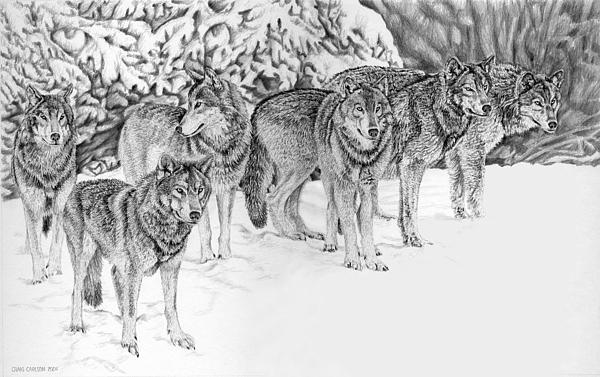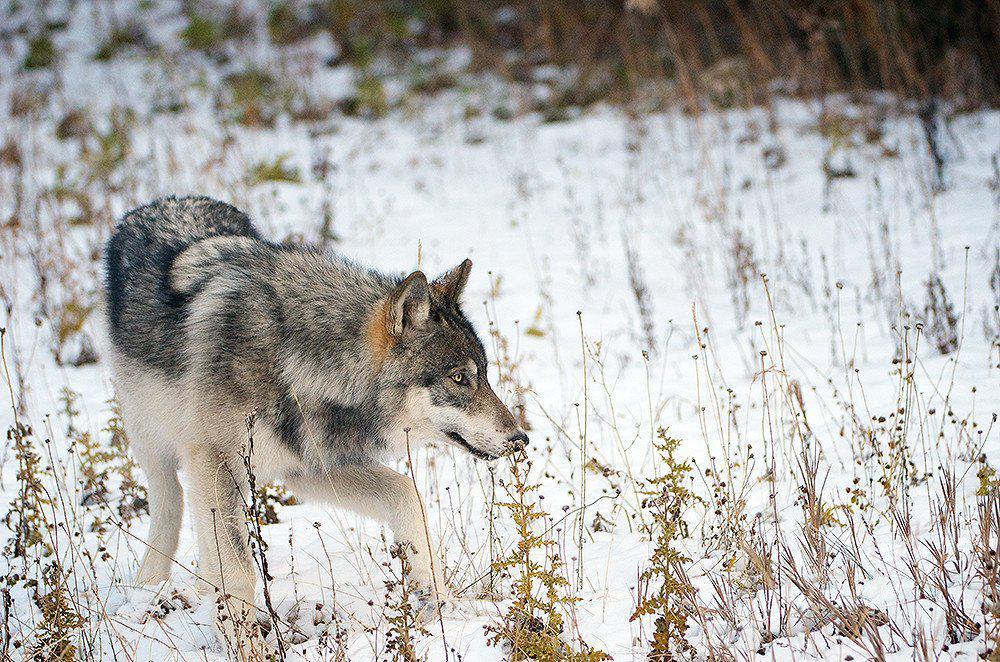The first image is the image on the left, the second image is the image on the right. Considering the images on both sides, is "Wolves are walking leftward in a straight line across snow-covered ground in one image." valid? Answer yes or no. No. The first image is the image on the left, the second image is the image on the right. Considering the images on both sides, is "The right image contains exactly one wolf." valid? Answer yes or no. Yes. 